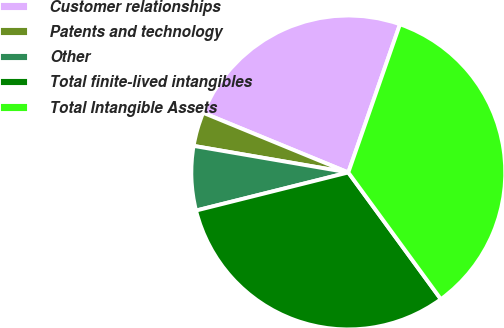Convert chart to OTSL. <chart><loc_0><loc_0><loc_500><loc_500><pie_chart><fcel>Customer relationships<fcel>Patents and technology<fcel>Other<fcel>Total finite-lived intangibles<fcel>Total Intangible Assets<nl><fcel>24.13%<fcel>3.5%<fcel>6.61%<fcel>31.14%<fcel>34.62%<nl></chart> 